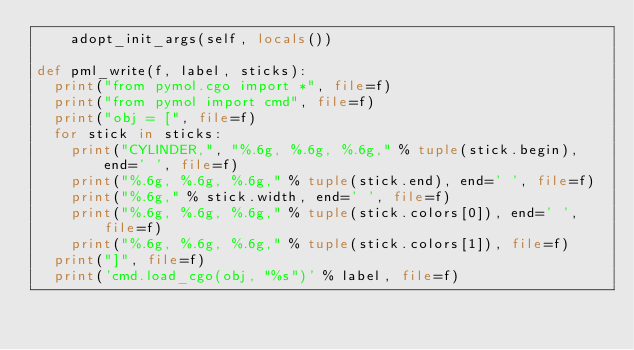<code> <loc_0><loc_0><loc_500><loc_500><_Python_>    adopt_init_args(self, locals())

def pml_write(f, label, sticks):
  print("from pymol.cgo import *", file=f)
  print("from pymol import cmd", file=f)
  print("obj = [", file=f)
  for stick in sticks:
    print("CYLINDER,", "%.6g, %.6g, %.6g," % tuple(stick.begin), end=' ', file=f)
    print("%.6g, %.6g, %.6g," % tuple(stick.end), end=' ', file=f)
    print("%.6g," % stick.width, end=' ', file=f)
    print("%.6g, %.6g, %.6g," % tuple(stick.colors[0]), end=' ', file=f)
    print("%.6g, %.6g, %.6g," % tuple(stick.colors[1]), file=f)
  print("]", file=f)
  print('cmd.load_cgo(obj, "%s")' % label, file=f)
</code> 